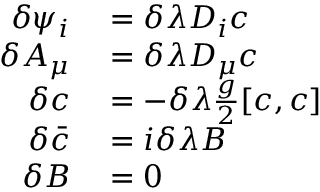Convert formula to latex. <formula><loc_0><loc_0><loc_500><loc_500>\begin{array} { r l } { \delta \psi _ { i } } & = \delta \lambda D _ { i } c } \\ { \delta A _ { \mu } } & = \delta \lambda D _ { \mu } c } \\ { \delta c } & = - \delta \lambda { \frac { g } { 2 } } [ c , c ] } \\ { \delta { \bar { c } } } & = i \delta \lambda B } \\ { \delta B } & = 0 } \end{array}</formula> 